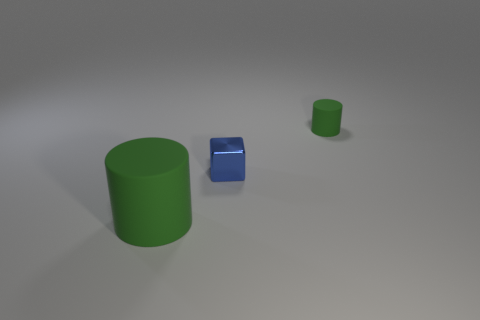What materials do the objects in this image look like they are made of? The objects in the image appear to be rendered with different material finishes. The larger cylinder and the smaller item to its right both have a matte surface that diffuses light softly, suggesting a possible plastic or rubber-like material. The block on the left, however, reflects light more sharply, indicating a metallic or polished material. 